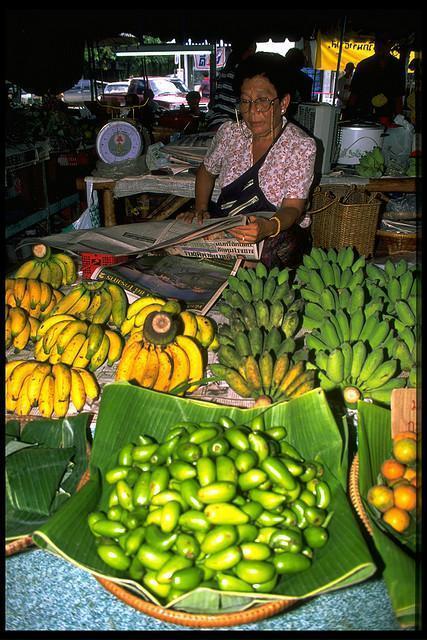How many people are visible?
Give a very brief answer. 2. How many bananas are there?
Give a very brief answer. 8. 